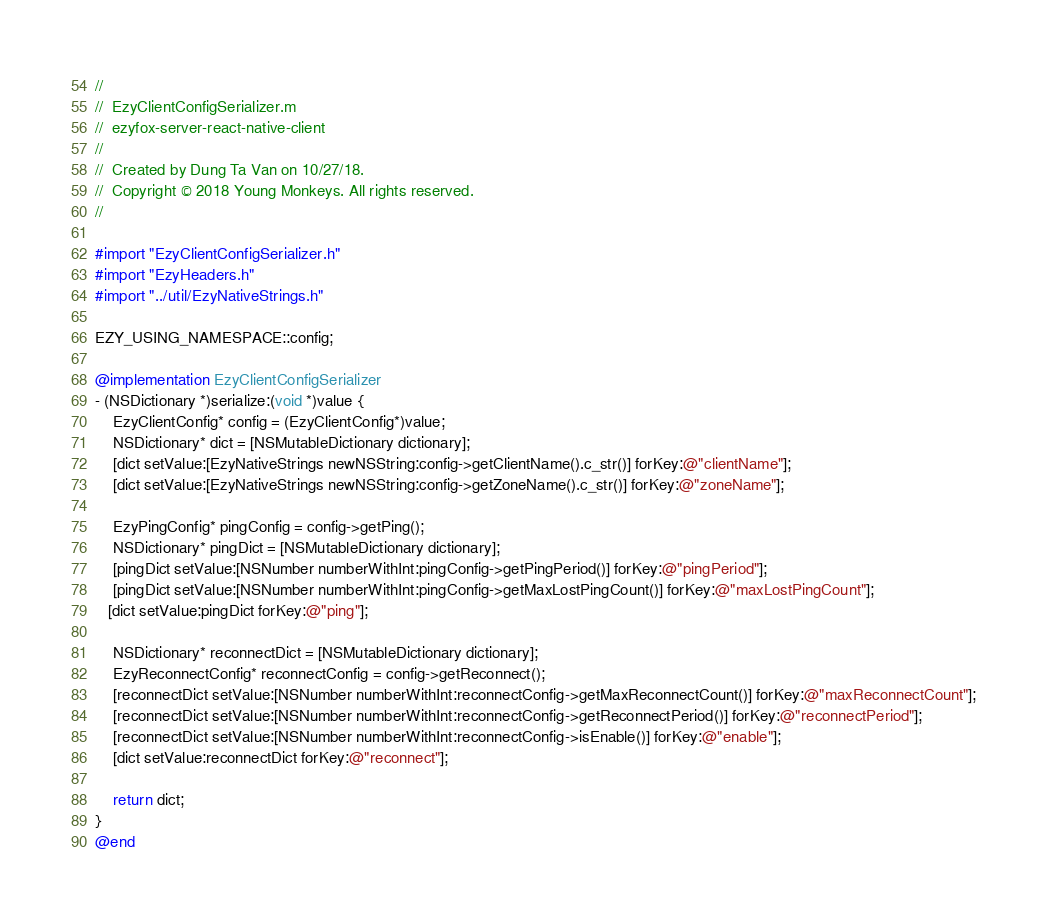<code> <loc_0><loc_0><loc_500><loc_500><_ObjectiveC_>//
//  EzyClientConfigSerializer.m
//  ezyfox-server-react-native-client
//
//  Created by Dung Ta Van on 10/27/18.
//  Copyright © 2018 Young Monkeys. All rights reserved.
//

#import "EzyClientConfigSerializer.h"
#import "EzyHeaders.h"
#import "../util/EzyNativeStrings.h"

EZY_USING_NAMESPACE::config;

@implementation EzyClientConfigSerializer
- (NSDictionary *)serialize:(void *)value {
    EzyClientConfig* config = (EzyClientConfig*)value;
    NSDictionary* dict = [NSMutableDictionary dictionary];
    [dict setValue:[EzyNativeStrings newNSString:config->getClientName().c_str()] forKey:@"clientName"];
    [dict setValue:[EzyNativeStrings newNSString:config->getZoneName().c_str()] forKey:@"zoneName"];
    
    EzyPingConfig* pingConfig = config->getPing();
    NSDictionary* pingDict = [NSMutableDictionary dictionary];
    [pingDict setValue:[NSNumber numberWithInt:pingConfig->getPingPeriod()] forKey:@"pingPeriod"];
    [pingDict setValue:[NSNumber numberWithInt:pingConfig->getMaxLostPingCount()] forKey:@"maxLostPingCount"];
   [dict setValue:pingDict forKey:@"ping"];
    
    NSDictionary* reconnectDict = [NSMutableDictionary dictionary];
    EzyReconnectConfig* reconnectConfig = config->getReconnect();
    [reconnectDict setValue:[NSNumber numberWithInt:reconnectConfig->getMaxReconnectCount()] forKey:@"maxReconnectCount"];
    [reconnectDict setValue:[NSNumber numberWithInt:reconnectConfig->getReconnectPeriod()] forKey:@"reconnectPeriod"];
    [reconnectDict setValue:[NSNumber numberWithInt:reconnectConfig->isEnable()] forKey:@"enable"];
    [dict setValue:reconnectDict forKey:@"reconnect"];
    
    return dict;
}
@end
</code> 